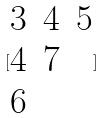<formula> <loc_0><loc_0><loc_500><loc_500>[ \begin{matrix} 3 & 4 & 5 \\ 4 & 7 \\ 6 \end{matrix} ]</formula> 